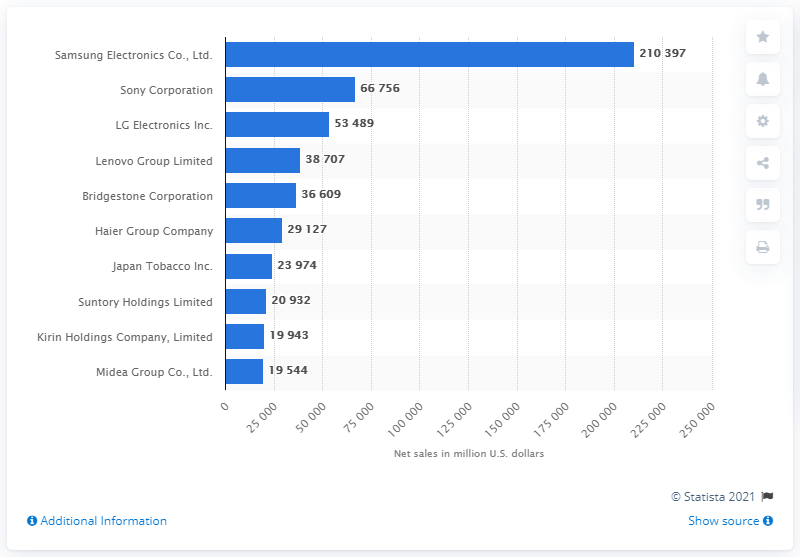Mention a couple of crucial points in this snapshot. In 2013, Japan Tobacco's global net sales were approximately 23,974 dollars. 